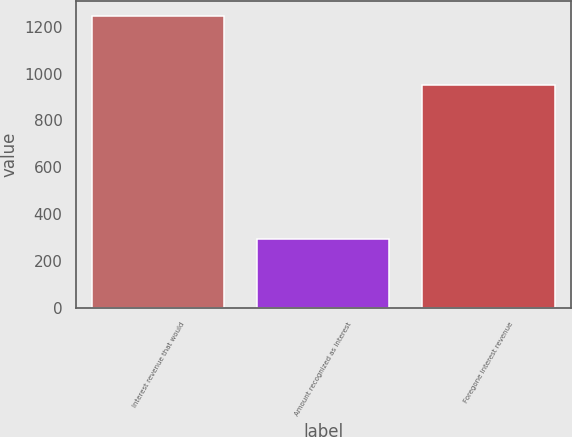Convert chart. <chart><loc_0><loc_0><loc_500><loc_500><bar_chart><fcel>Interest revenue that would<fcel>Amount recognized as interest<fcel>Foregone interest revenue<nl><fcel>1245<fcel>295<fcel>950<nl></chart> 